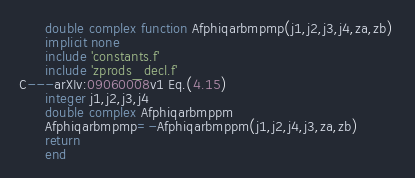Convert code to text. <code><loc_0><loc_0><loc_500><loc_500><_FORTRAN_>      double complex function Afphiqarbmpmp(j1,j2,j3,j4,za,zb) 
      implicit none 
      include 'constants.f'
      include 'zprods_decl.f'
C---arXIv:09060008v1 Eq.(4.15)
      integer j1,j2,j3,j4
      double complex Afphiqarbmppm
      Afphiqarbmpmp=-Afphiqarbmppm(j1,j2,j4,j3,za,zb)
      return
      end

</code> 